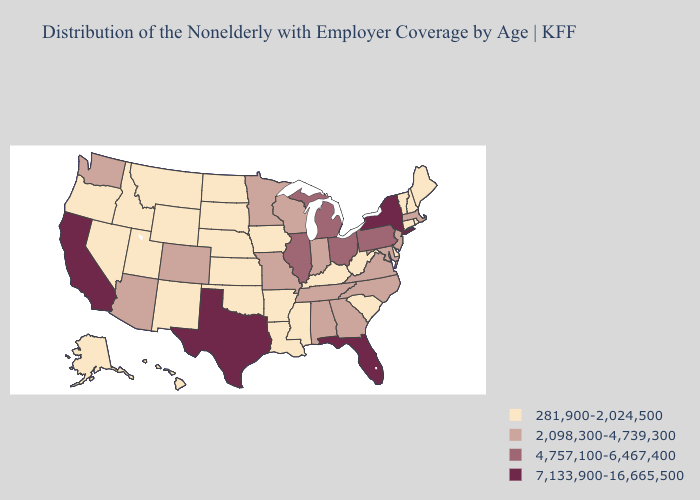How many symbols are there in the legend?
Short answer required. 4. Among the states that border Illinois , does Missouri have the lowest value?
Concise answer only. No. What is the lowest value in states that border Tennessee?
Be succinct. 281,900-2,024,500. What is the lowest value in states that border Rhode Island?
Give a very brief answer. 281,900-2,024,500. Name the states that have a value in the range 281,900-2,024,500?
Give a very brief answer. Alaska, Arkansas, Connecticut, Delaware, Hawaii, Idaho, Iowa, Kansas, Kentucky, Louisiana, Maine, Mississippi, Montana, Nebraska, Nevada, New Hampshire, New Mexico, North Dakota, Oklahoma, Oregon, Rhode Island, South Carolina, South Dakota, Utah, Vermont, West Virginia, Wyoming. What is the lowest value in the West?
Short answer required. 281,900-2,024,500. Does Alaska have the lowest value in the USA?
Answer briefly. Yes. What is the value of California?
Concise answer only. 7,133,900-16,665,500. Name the states that have a value in the range 2,098,300-4,739,300?
Give a very brief answer. Alabama, Arizona, Colorado, Georgia, Indiana, Maryland, Massachusetts, Minnesota, Missouri, New Jersey, North Carolina, Tennessee, Virginia, Washington, Wisconsin. What is the value of Idaho?
Answer briefly. 281,900-2,024,500. Name the states that have a value in the range 281,900-2,024,500?
Give a very brief answer. Alaska, Arkansas, Connecticut, Delaware, Hawaii, Idaho, Iowa, Kansas, Kentucky, Louisiana, Maine, Mississippi, Montana, Nebraska, Nevada, New Hampshire, New Mexico, North Dakota, Oklahoma, Oregon, Rhode Island, South Carolina, South Dakota, Utah, Vermont, West Virginia, Wyoming. Does the first symbol in the legend represent the smallest category?
Give a very brief answer. Yes. What is the lowest value in states that border Connecticut?
Quick response, please. 281,900-2,024,500. What is the value of Wyoming?
Quick response, please. 281,900-2,024,500. Does the map have missing data?
Keep it brief. No. 